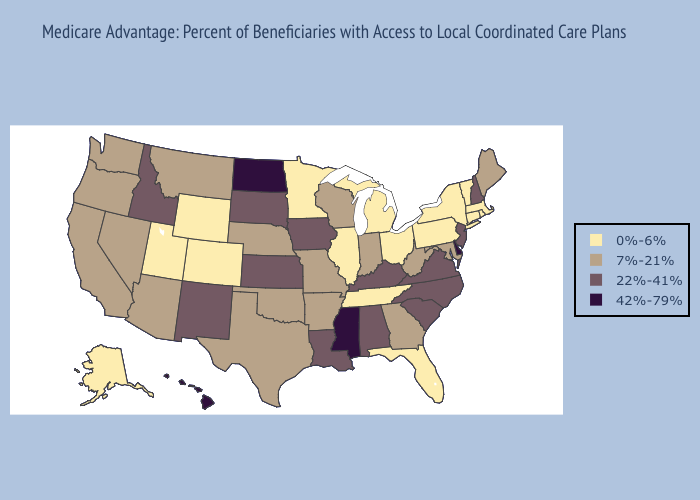What is the highest value in the USA?
Short answer required. 42%-79%. Among the states that border New Mexico , does Texas have the lowest value?
Write a very short answer. No. Does New York have the highest value in the Northeast?
Keep it brief. No. Does New Hampshire have the lowest value in the Northeast?
Concise answer only. No. Name the states that have a value in the range 22%-41%?
Keep it brief. Iowa, Idaho, Kansas, Kentucky, Louisiana, North Carolina, New Hampshire, New Jersey, New Mexico, South Carolina, South Dakota, Virginia, Alabama. Does West Virginia have the same value as Pennsylvania?
Be succinct. No. Name the states that have a value in the range 0%-6%?
Answer briefly. Colorado, Connecticut, Florida, Illinois, Massachusetts, Michigan, Minnesota, New York, Ohio, Pennsylvania, Rhode Island, Alaska, Tennessee, Utah, Vermont, Wyoming. Does Arizona have the same value as South Carolina?
Be succinct. No. Name the states that have a value in the range 7%-21%?
Write a very short answer. California, Georgia, Indiana, Maryland, Maine, Missouri, Montana, Nebraska, Nevada, Oklahoma, Oregon, Texas, Washington, Wisconsin, West Virginia, Arkansas, Arizona. Does Louisiana have the same value as North Carolina?
Give a very brief answer. Yes. What is the value of Kentucky?
Be succinct. 22%-41%. What is the value of Arkansas?
Concise answer only. 7%-21%. Name the states that have a value in the range 0%-6%?
Answer briefly. Colorado, Connecticut, Florida, Illinois, Massachusetts, Michigan, Minnesota, New York, Ohio, Pennsylvania, Rhode Island, Alaska, Tennessee, Utah, Vermont, Wyoming. What is the value of Connecticut?
Keep it brief. 0%-6%. Name the states that have a value in the range 0%-6%?
Keep it brief. Colorado, Connecticut, Florida, Illinois, Massachusetts, Michigan, Minnesota, New York, Ohio, Pennsylvania, Rhode Island, Alaska, Tennessee, Utah, Vermont, Wyoming. 